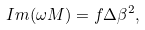<formula> <loc_0><loc_0><loc_500><loc_500>I m ( \omega M ) = f \Delta \beta ^ { 2 } ,</formula> 